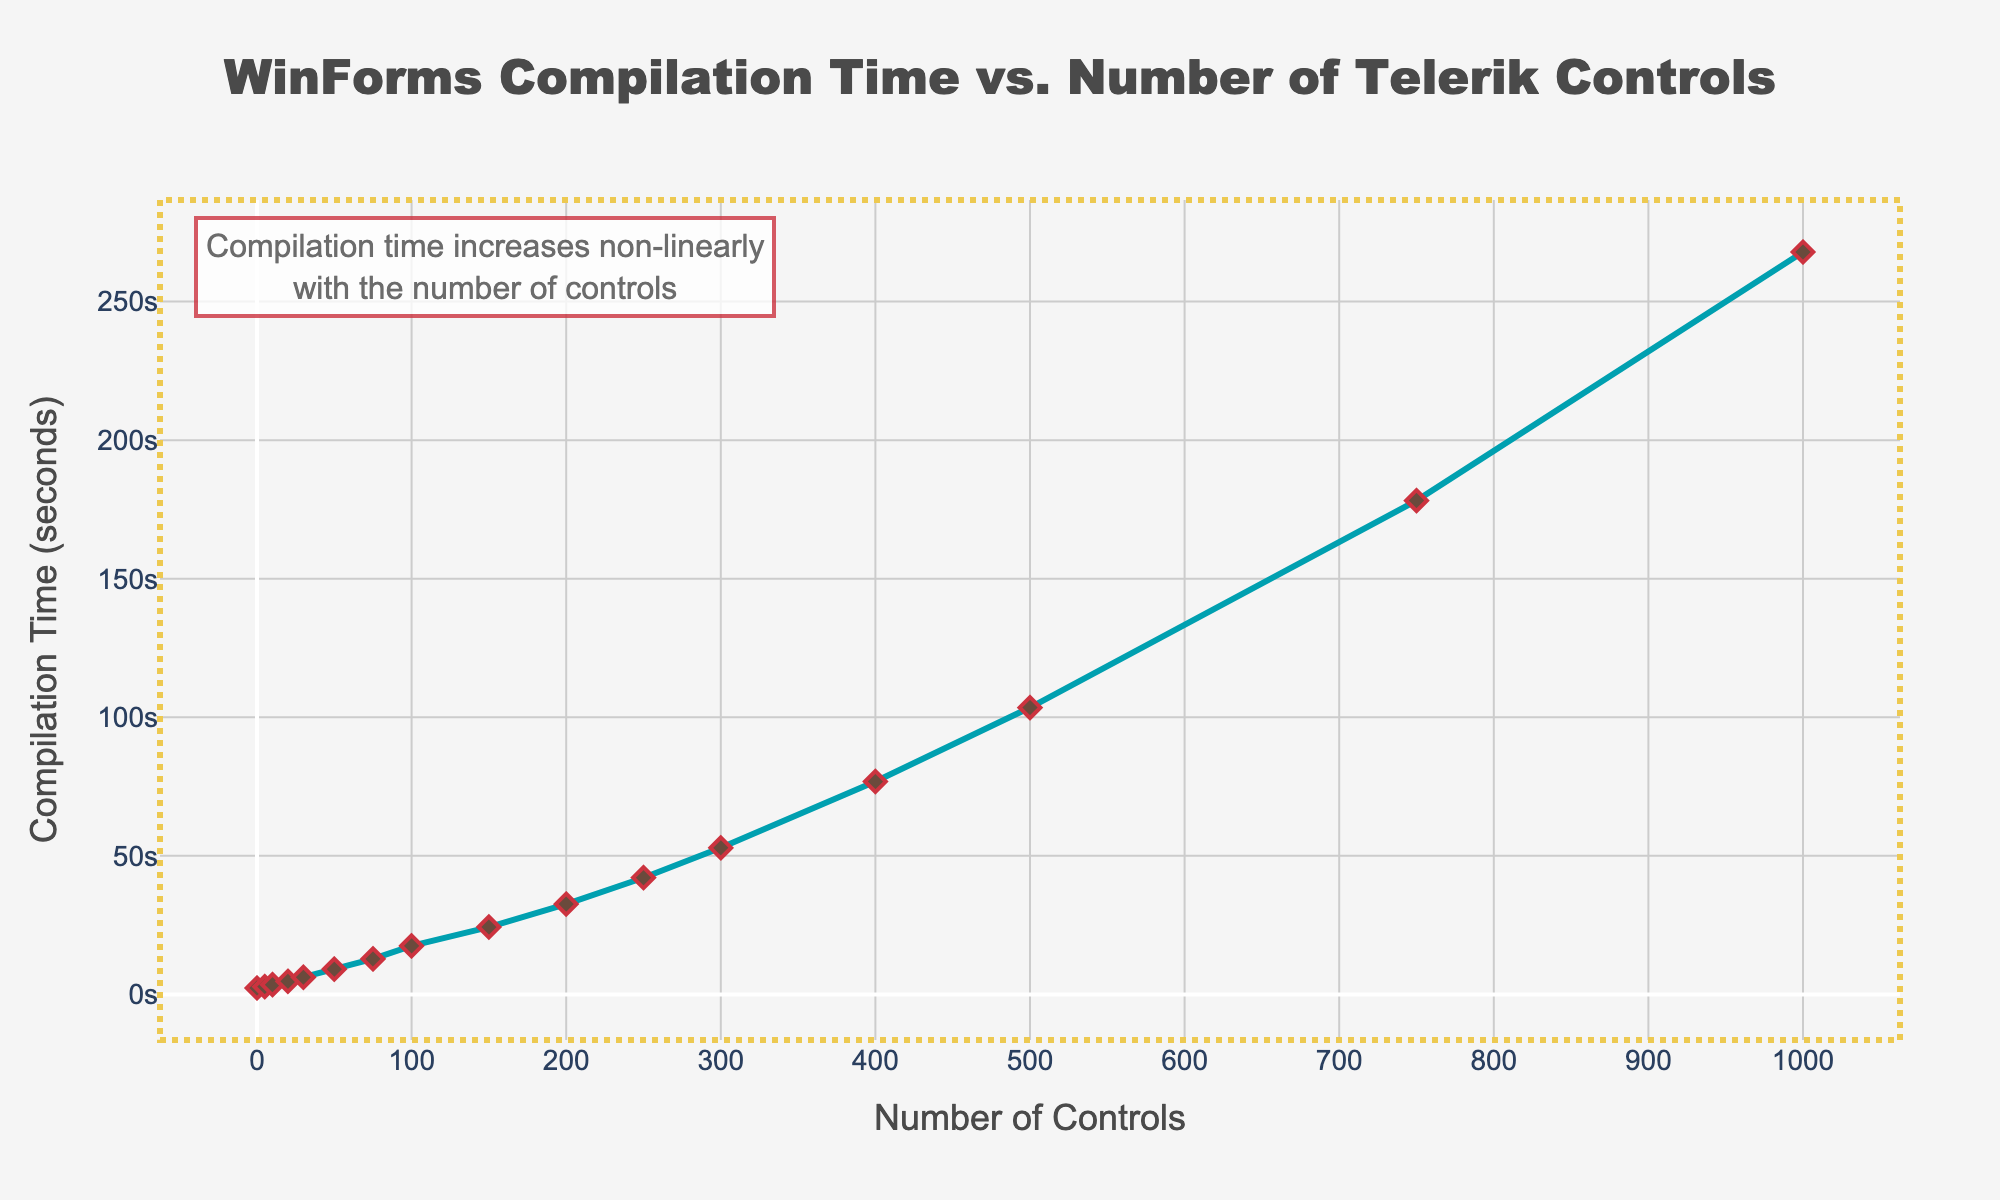How does the compilation time change as the number of controls increases from 0 to 10? At 0 controls, the compilation time is 2.3 seconds. When the number of controls increases to 10, the compilation time increases to 3.5 seconds. The increase in compilation time is 3.5 - 2.3 = 1.2 seconds.
Answer: 1.2 seconds What's the difference in compilation time between using 50 and 300 Telerik controls? At 50 controls, the compilation time is 9.1 seconds, and at 300 controls, it is 52.9 seconds. The difference is 52.9 - 9.1 = 43.8 seconds.
Answer: 43.8 seconds Which interval exhibits the largest increase in compilation time: from 100 to 150 controls or from 400 to 500 controls? The compilation time increases from 17.5 seconds at 100 controls to 24.3 seconds at 150 controls, a difference of 24.3 - 17.5 = 6.8 seconds. From 400 to 500 controls, the compilation time increases from 76.8 seconds to 103.5 seconds, a difference of 103.5 - 76.8 = 26.7 seconds. Therefore, the interval from 400 to 500 controls has the largest increase.
Answer: 400 to 500 controls By approximately how much does the compilation time increase for every additional 100 controls between 200 and 500 controls? From 200 to 500 controls, the compilation time increases from 32.6 seconds to 103.5 seconds. The total increase is 103.5 - 32.6 = 70.9 seconds. Over this range of 300 controls (500-200), the average increase per 100 controls is 70.9 / 3 = 23.63 seconds.
Answer: 23.63 seconds Is the trend of the compilation time increasing with the number of controls linear or non-linear according to the annotation on the figure? The annotation on the figure states that the compilation time increases non-linearly with the number of controls. Therefore, the trend is non-linear.
Answer: Non-linear What is the compilation time when the number of controls is doubled from 150 to 300? At 150 controls, the compilation time is 24.3 seconds. When the number of controls doubles to 300, the compilation time increases to 52.9 seconds.
Answer: 52.9 seconds By what factor does the compilation time increase when moving from 75 to 750 controls? At 75 controls, the compilation time is 12.8 seconds. At 750 controls, it is 178.2 seconds. The factor is 178.2 / 12.8 ≈ 13.9.
Answer: 13.9 How does the gridline pattern on both axes help in interpreting the graph? The gridlines on both axes create a reference framework, making it easier to determine the exact values of the data points and compare the compilation times at different numbers of controls.
Answer: Provides a reference framework Describe the visual appearance of the annotation box in the figure. The annotation box is positioned in the top left corner with text indicating the non-linear increase in compilation time. It's styled with a white background, bordered edges, and a light opacity, surrounded by a dotted rectangular shape highlighted in yellow.
Answer: Top left, white background, bordered edges, light opacity, dotted yellow rectangle 